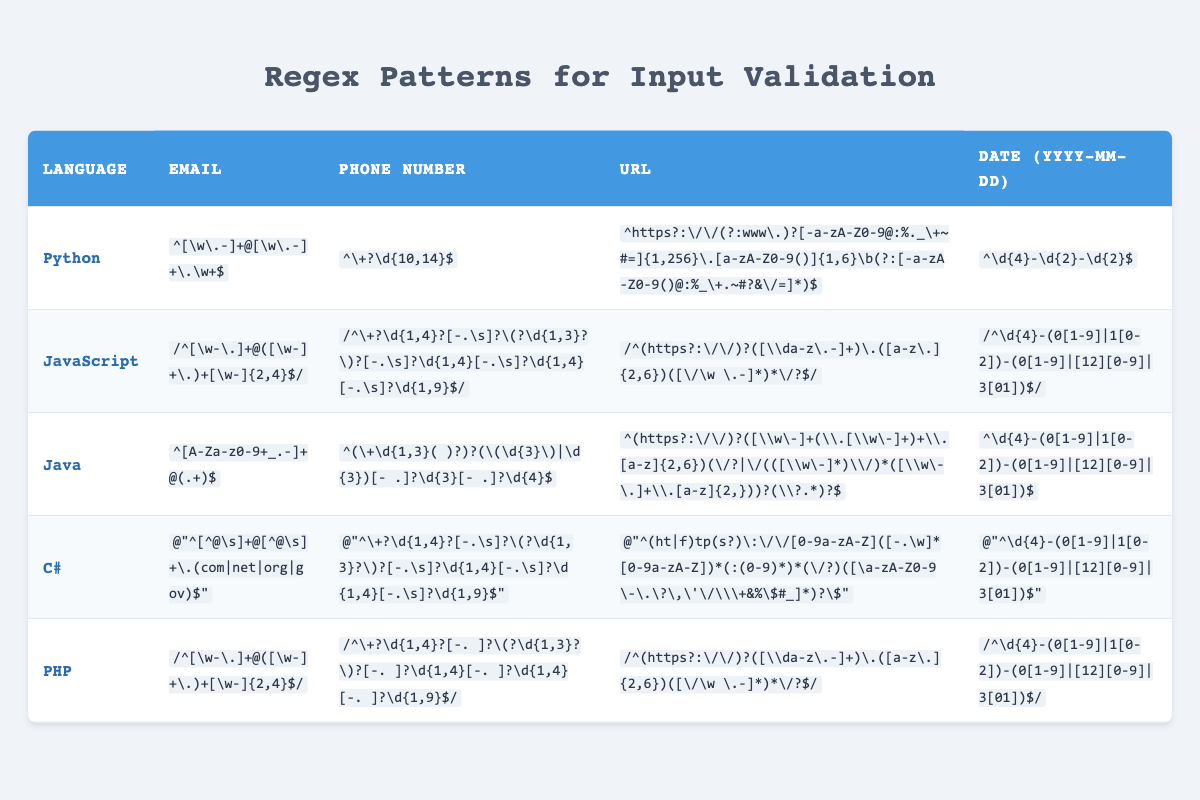What regex pattern is used for email validation in Java? The table shows that the regex pattern for email validation in Java is "^[A-Za-z0-9+_.-]+@(.+)$".
Answer: ^[A-Za-z0-9+_.-]+@(.+)$ Which programming languages use the same regex pattern for URL validation? By inspecting the table, it reveals that Python, JavaScript, and PHP all use similar patterns for URL validation, but the exact patterns differ, indicating no exact matches.
Answer: None Is the regex for phone number validation in Python the same as that in PHP? The phone number regex for Python is "^\+?\d{10,14}$" and for PHP is "^\+?\d{1,4}?[-. ]?\(?\d{1,3}?\)?[-. ]?\d{1,4}[-. ]?\d{1,4}[-. ]?\d{1,9}$". They are different patterns.
Answer: No Which programming language regex for email allows for multiple domain extensions? The regex pattern for email in Java allows multiple domain extensions with the format "^[A-Za-z0-9+_.-]+@(.+)$", which indicates there can be many characters after the @ symbol.
Answer: Java What's the total number of programming languages listed in the table? Counting the rows in the table, there are five programming languages: Python, JavaScript, Java, C#, and PHP. Thus, the total is five.
Answer: 5 Do any regex patterns for phone number validation include optional country codes? Yes, the patterns for phone validation in Python, JavaScript, Java, and C# all include optional country code formats by having the "+" character at the start of the regex pattern.
Answer: Yes 